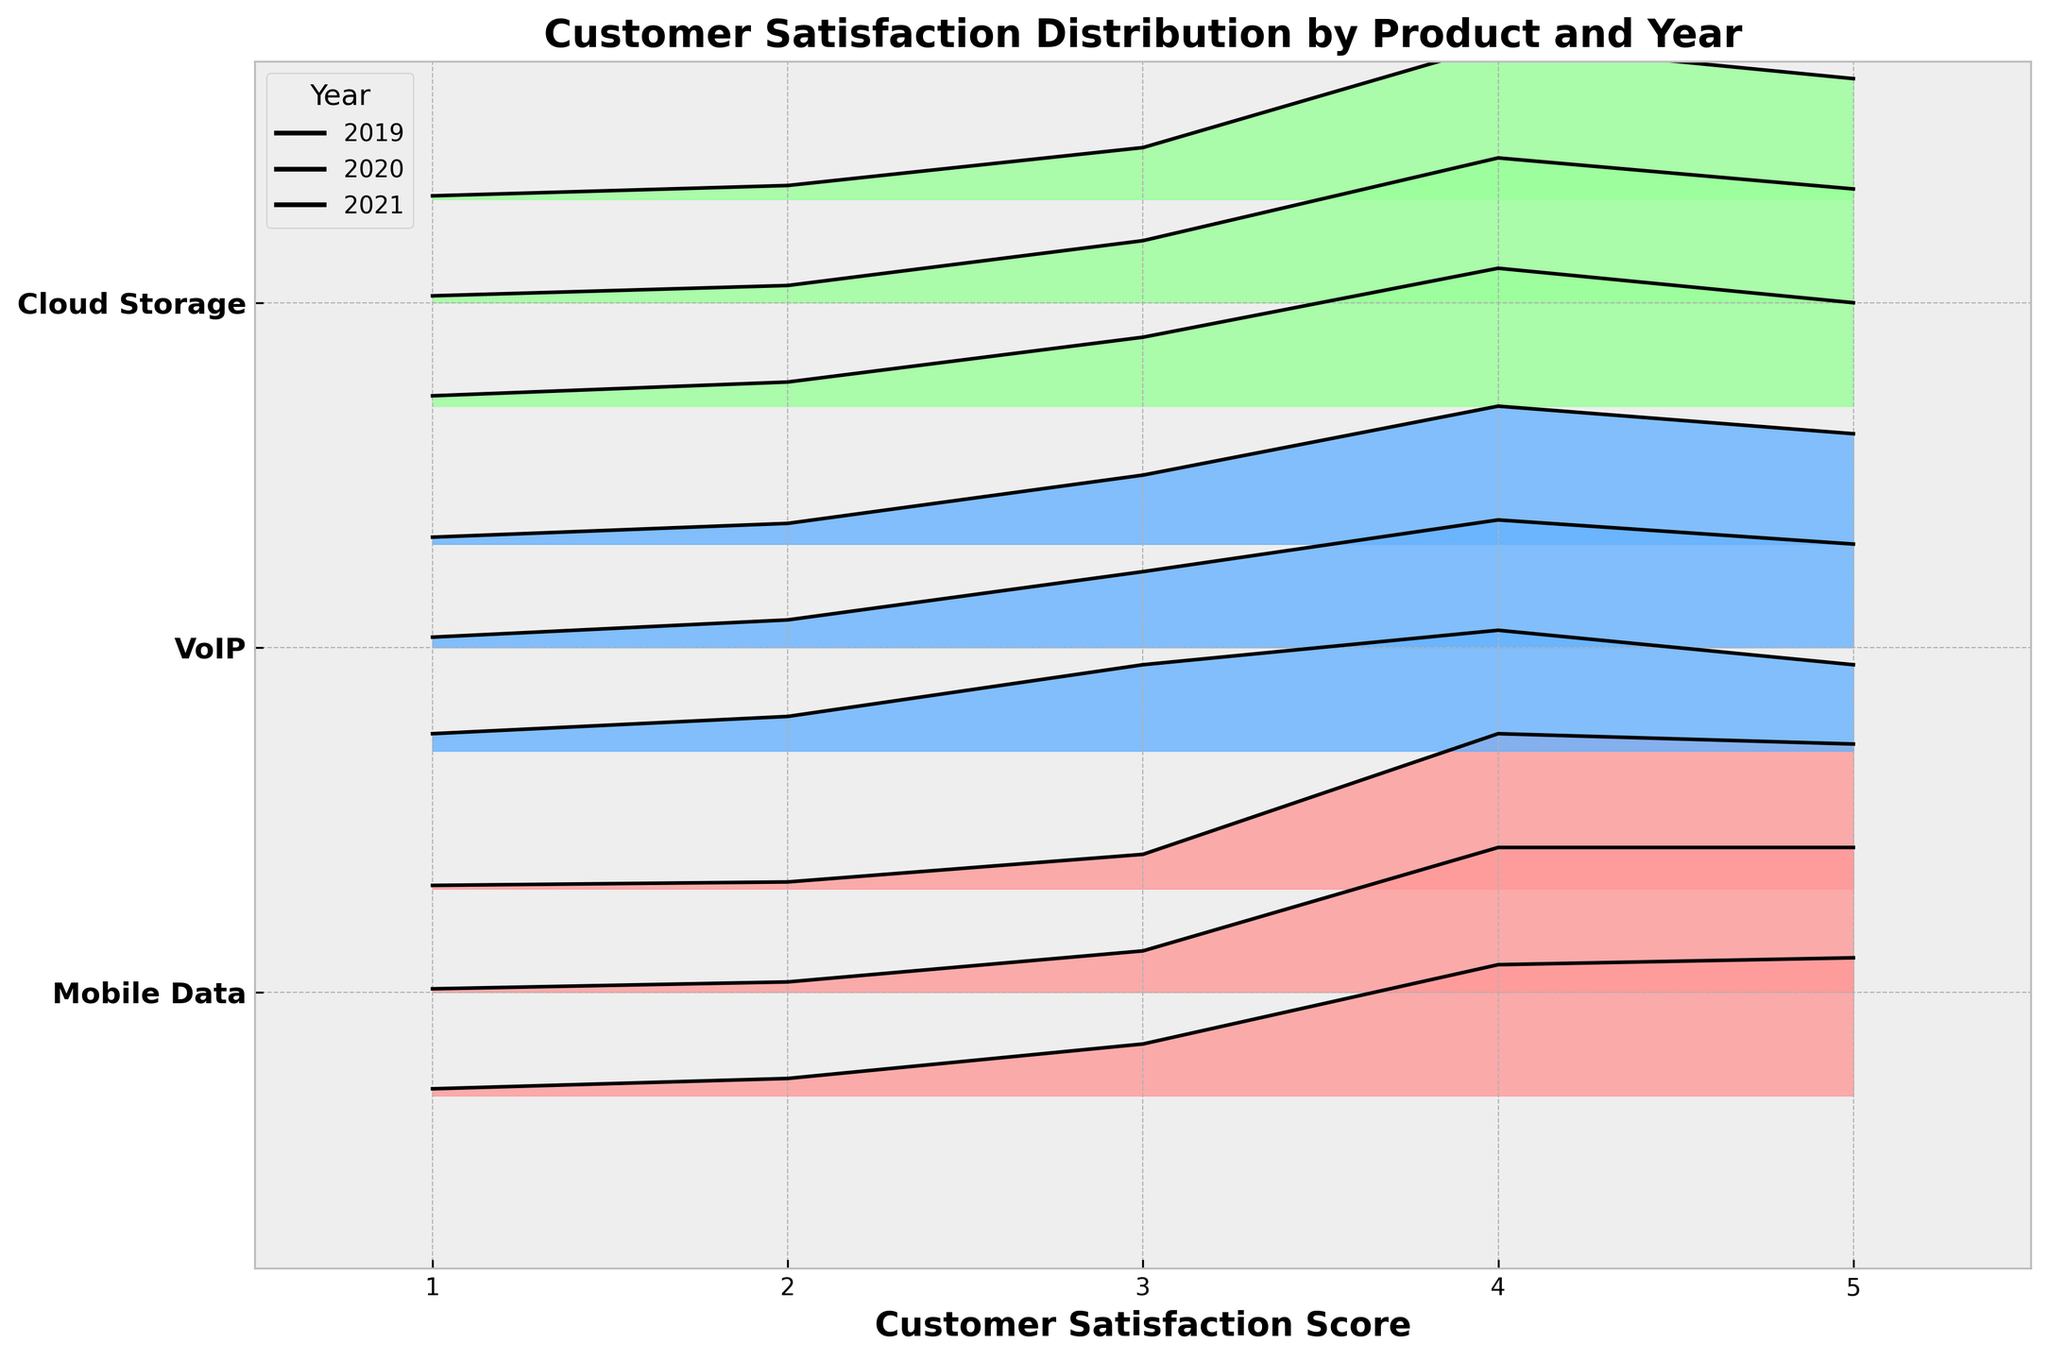What is the title of the plot? The title is written at the top of the plot. It reads 'Customer Satisfaction Distribution by Product and Year'.
Answer: Customer Satisfaction Distribution by Product and Year How many products are displayed in the ridgeline plot? The y-axis lists the products, read from the plot, there are three products: Mobile Data, VoIP, and Cloud Storage.
Answer: 3 Which year has the highest density for the Mobile Data product? For Mobile Data, look at the highest peak in the plot for each year. The year 2021 has the highest peak, reaching around 0.45.
Answer: 2021 What do the colors represent in the plot? Different color bands in the plot correspond to different products.
Answer: Products How does the customer satisfaction for Cloud Storage in 2021 compare to 2019? Comparing the heights of the ridgelines, Cloud Storage in 2021 has a higher peak (around 0.45) compared to 2019 (around 0.40).
Answer: Higher in 2021 In which year did VoIP have the lowest satisfaction density? The lowest peaks for VoIP across the years can be identified. VoIP had the lowest peak in 2019 at 1 rating with 0.05 density.
Answer: 2019 What is the customer satisfaction score range represented in the plot? The x-axis represents the customer satisfaction scores, ranging from 1 to 5.
Answer: 1 to 5 Which product shows a consistent improvement in customer satisfaction from 2019 to 2021? Comparing the peaks of each product over the three years, Mobile Data shows consistent improvement, with peaks increasing from 0.40 in 2019 to 0.42 in 2020 and 2021.
Answer: Mobile Data How does the distribution of customer satisfaction scores for the Mobile Data product change over time? Over time, the peak density of satisfaction scores for Mobile Data increases, showing higher frequencies at scores of 4 and 5 from 2019 to 2021.
Answer: Densities increase over time 